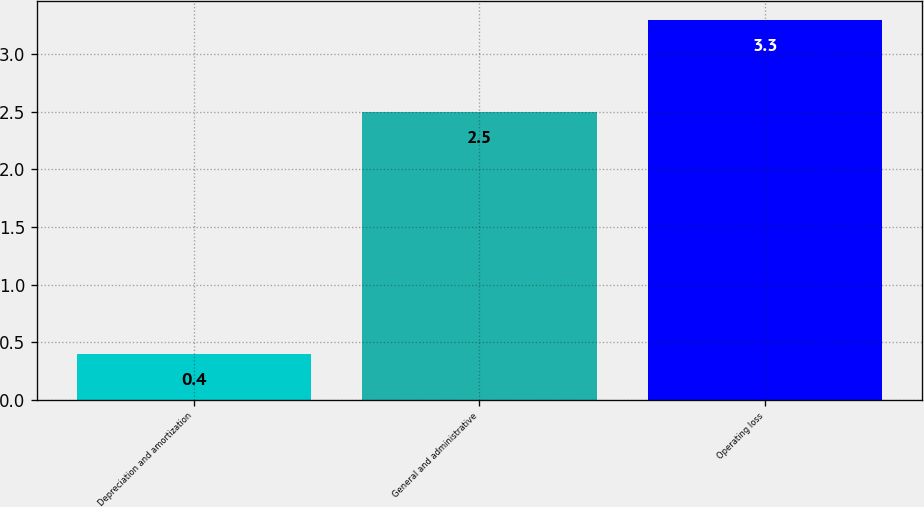Convert chart to OTSL. <chart><loc_0><loc_0><loc_500><loc_500><bar_chart><fcel>Depreciation and amortization<fcel>General and administrative<fcel>Operating loss<nl><fcel>0.4<fcel>2.5<fcel>3.3<nl></chart> 